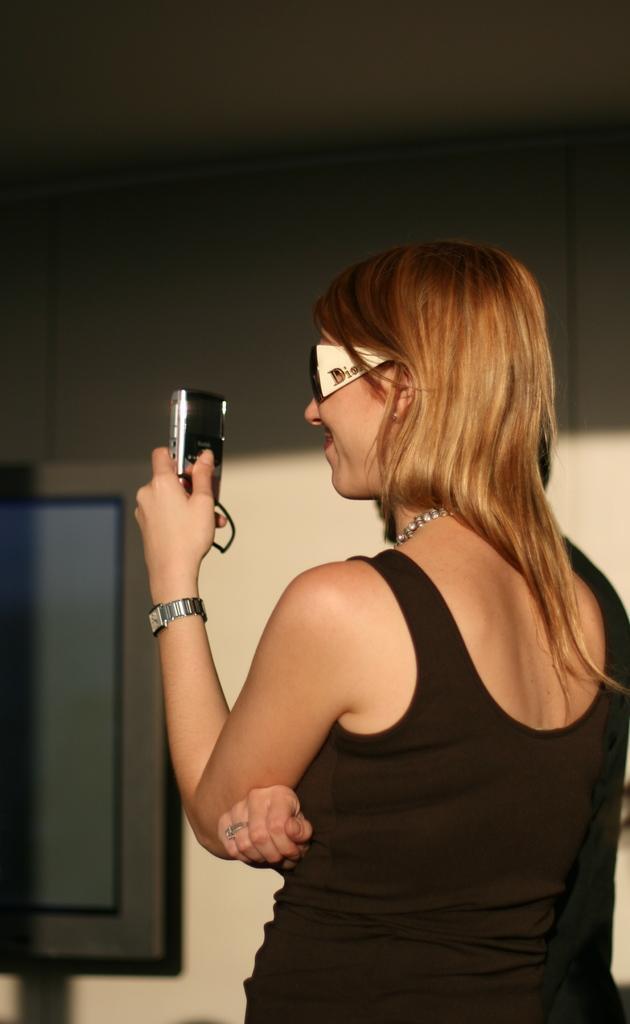Describe this image in one or two sentences. In this image, we can see a woman standing, she is wearing specs, she is holding a camera, in the background there is a wall and we can see a window door. 